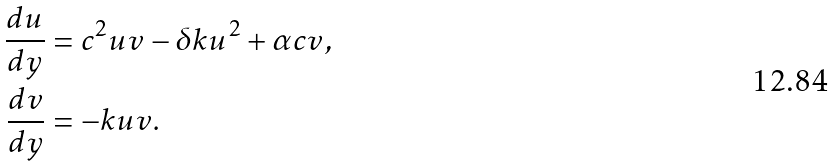Convert formula to latex. <formula><loc_0><loc_0><loc_500><loc_500>\frac { d u } { d y } & = c ^ { 2 } u v - \delta k u ^ { 2 } + \alpha c v , \\ \frac { d v } { d y } & = - k u v .</formula> 